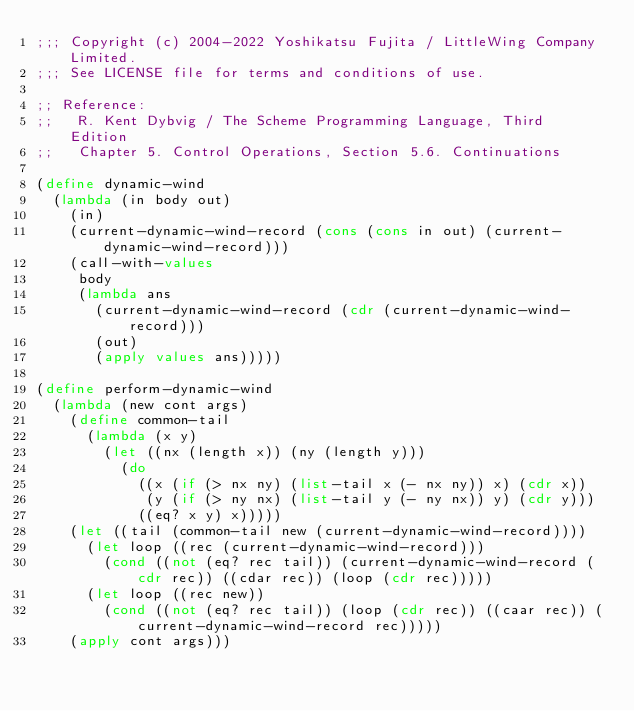Convert code to text. <code><loc_0><loc_0><loc_500><loc_500><_Scheme_>;;; Copyright (c) 2004-2022 Yoshikatsu Fujita / LittleWing Company Limited.
;;; See LICENSE file for terms and conditions of use.

;; Reference:
;;   R. Kent Dybvig / The Scheme Programming Language, Third Edition
;;   Chapter 5. Control Operations, Section 5.6. Continuations

(define dynamic-wind
  (lambda (in body out)
    (in)
    (current-dynamic-wind-record (cons (cons in out) (current-dynamic-wind-record)))
    (call-with-values
     body
     (lambda ans
       (current-dynamic-wind-record (cdr (current-dynamic-wind-record)))
       (out)
       (apply values ans)))))

(define perform-dynamic-wind
  (lambda (new cont args)
    (define common-tail
      (lambda (x y)
        (let ((nx (length x)) (ny (length y)))
          (do
            ((x (if (> nx ny) (list-tail x (- nx ny)) x) (cdr x))
             (y (if (> ny nx) (list-tail y (- ny nx)) y) (cdr y)))
            ((eq? x y) x)))))
    (let ((tail (common-tail new (current-dynamic-wind-record))))
      (let loop ((rec (current-dynamic-wind-record)))
        (cond ((not (eq? rec tail)) (current-dynamic-wind-record (cdr rec)) ((cdar rec)) (loop (cdr rec)))))
      (let loop ((rec new))
        (cond ((not (eq? rec tail)) (loop (cdr rec)) ((caar rec)) (current-dynamic-wind-record rec)))))
    (apply cont args)))
</code> 